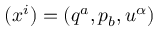<formula> <loc_0><loc_0><loc_500><loc_500>( x ^ { i } ) = ( q ^ { a } , p _ { b } , u ^ { \alpha } )</formula> 